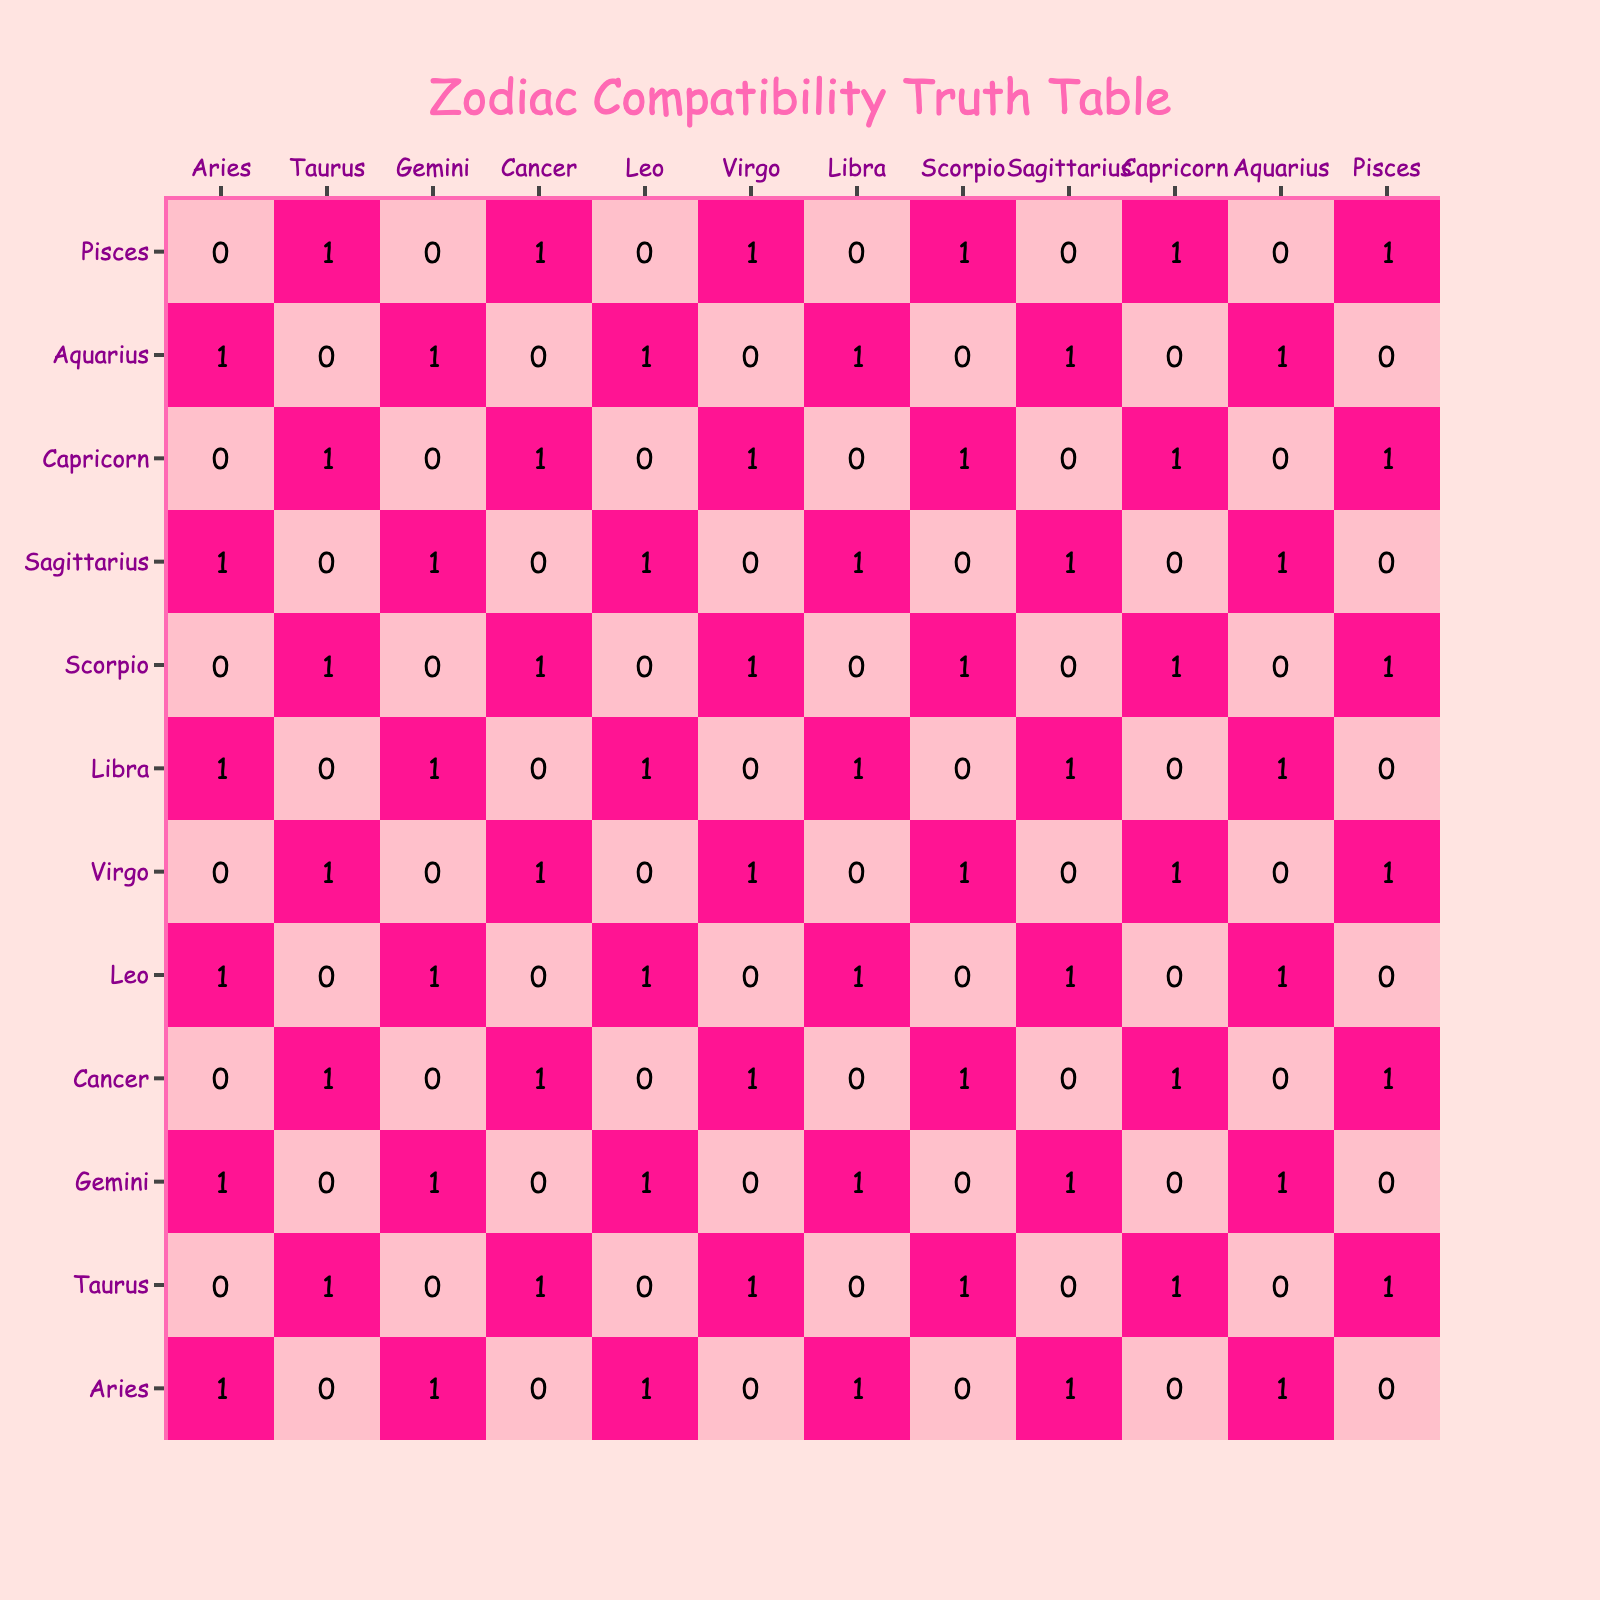What is the compatibility score between Aries and Taurus? By checking the row for Aries and the column for Taurus in the table, we see the value is 0, indicating a lack of compatibility.
Answer: 0 How many zodiac signs are compatible with Leo? Looking at the row for Leo, there are five signs (Aries, Gemini, Leo, Sagittarius, Aquarius) with a score of 1, indicating compatibility.
Answer: 5 Is Cancer compatible with Capricorn? In the table, under the Cancer row and Capricorn column, the score is 1, indicating that these two signs are compatible.
Answer: Yes What is the total number of compatible pairs for Scorpio? From the Scorpio row, the corresponding values are (0, 1, 0, 1, 0, 1, 0, 1) which yield a sum of 4 when counting the 1's. Therefore, Scorpio is compatible with 4 signs.
Answer: 4 Which zodiac signs show compatibility with Pisces? Examining the row for Pisces, the compatible zodiac signs are Taurus, Cancer, Virgo, Scorpio, and Capricorn, as each has an associated score of 1.
Answer: Taurus, Cancer, Virgo, Scorpio, Capricorn What is the total number of compatible zodiac signs among all signs? Summing all scores (1's) in the table gives a total count of compatibility pairs. The total is 30, as each sign has 5 compatible partners.
Answer: 30 Are Gemini and Virgo compatible? Checking the table, under Gemini and the Virgo column shows a score of 0, meaning they are not compatible.
Answer: No Which zodiac sign has the most compatible pairs? By examining the total number of 1's in each row, Gemini, Leo, Sagittarius, and Aquarius each have 6 compatibility scores, indicating they have the most compatible pairs.
Answer: Gemini, Leo, Sagittarius, Aquarius 